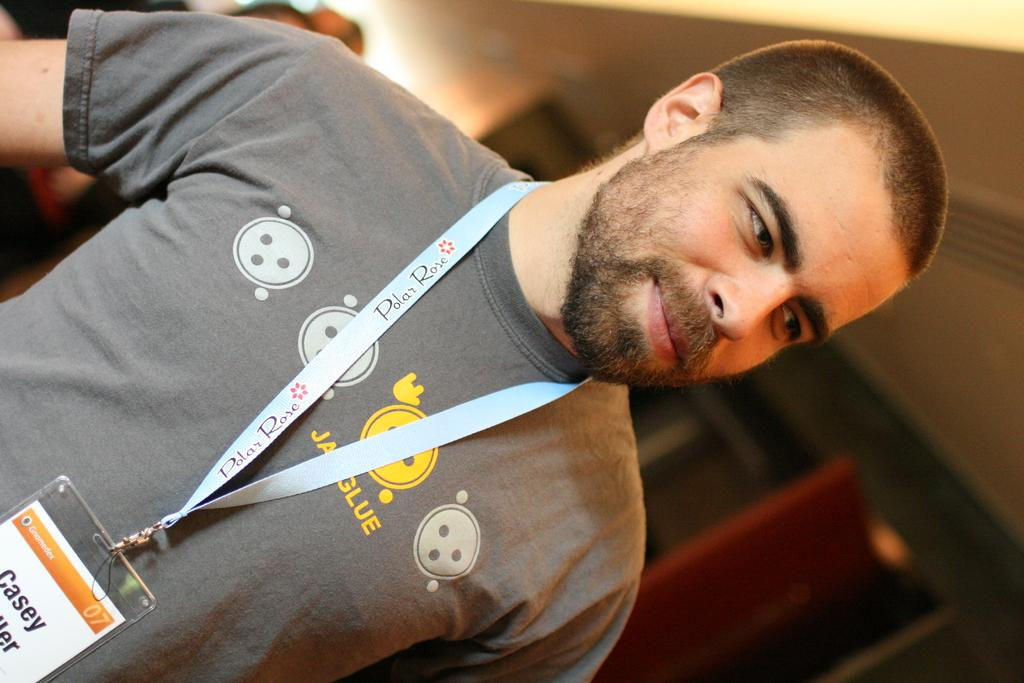What is the main subject of the image? There is a man standing in the image. Can you describe what the man is wearing? The man is wearing an ID card. What architectural feature can be seen in the image? There is a door visible in the image. What part of a building is visible in the image? There is a roof visible in the image. Can you hear the man crying in the image? There is no indication of the man crying in the image, and no sound is present. 